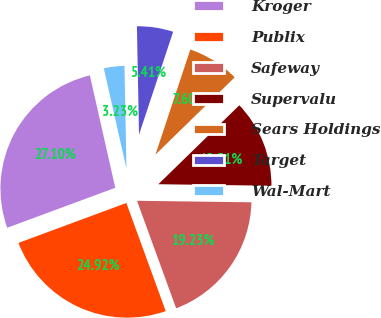Convert chart to OTSL. <chart><loc_0><loc_0><loc_500><loc_500><pie_chart><fcel>Kroger<fcel>Publix<fcel>Safeway<fcel>Supervalu<fcel>Sears Holdings<fcel>Target<fcel>Wal-Mart<nl><fcel>27.1%<fcel>24.92%<fcel>19.23%<fcel>12.51%<fcel>7.6%<fcel>5.41%<fcel>3.23%<nl></chart> 